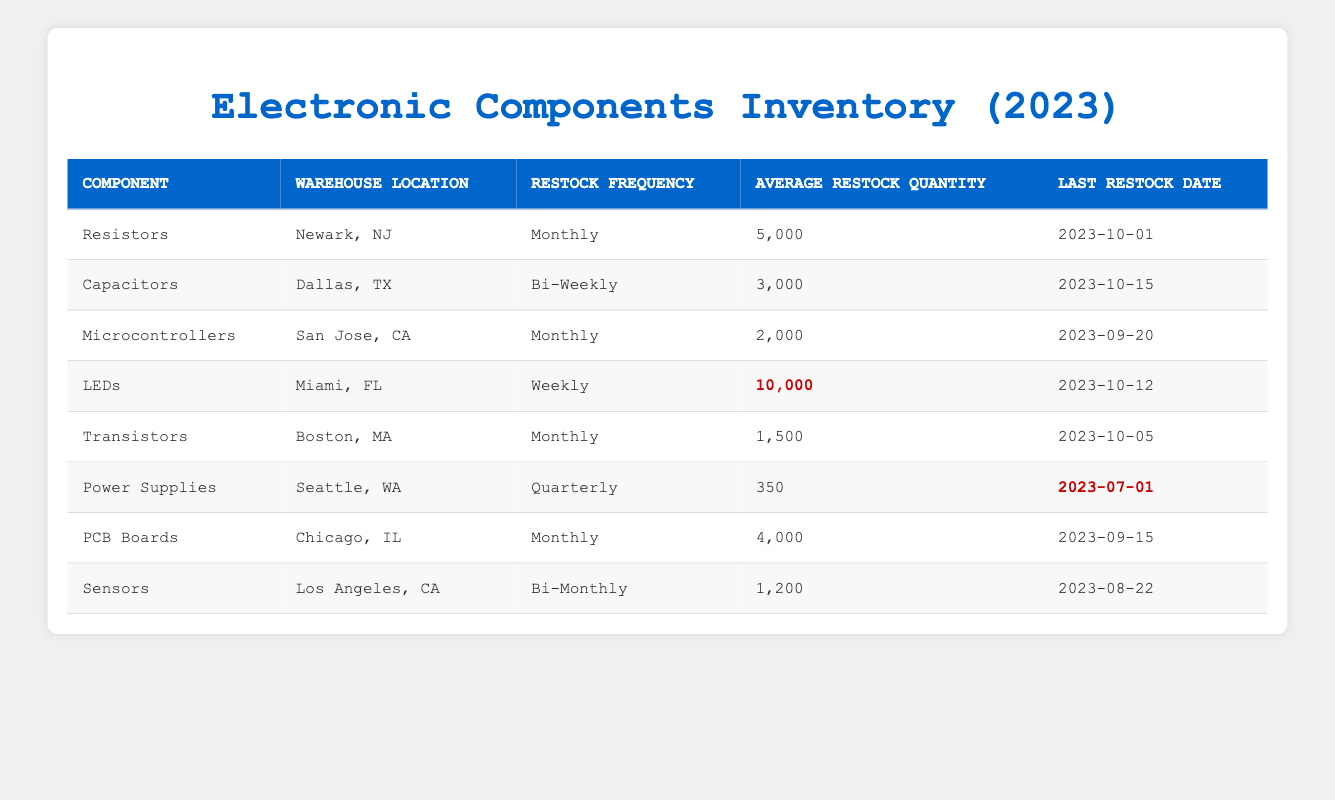What is the restock frequency of LEDs? The row for LEDs shows their Restock Frequency is Weekly.
Answer: Weekly How many components are restocked monthly? The table lists the components with restock frequency as Monthly: Resistors, Microcontrollers, Transistors, and PCB Boards. That totals to 4 components.
Answer: 4 Which component has the highest average restock quantity? By comparing the Average Restock Quantity, LEDs, with 10,000, is the highest value among the components listed.
Answer: 10,000 Is Power Supplies restocked more frequently than Sensors? Power Supplies have a Quarterly restock frequency while Sensors are Bi-Monthly. Quarterly means every three months, which is less frequent than Bi-Monthly (every two months). Therefore, the statement is false.
Answer: No What is the combined average restock quantity of the components that are restocked monthly? To find the combined average restock quantity of the monthly components: Resistors (5000) + Microcontrollers (2000) + Transistors (1500) + PCB Boards (4000) = 13,500. There are 4 components, so the average is 13,500/4 = 3,375.
Answer: 3,375 Which warehouse location has the last restock date among the components? Checking the Last Restock Date column, the latest date is for Capacitors at 2023-10-15.
Answer: Dallas, TX Are there any components with a restock frequency of Bi-Weekly? The table shows that Capacitors are listed with a Bi-Weekly restock frequency, meaning the answer is yes.
Answer: Yes Do all components with a monthly restock frequency have the same warehouse location? The monthly components are located in Newark, NJ (Resistors), San Jose, CA (Microcontrollers), Boston, MA (Transistors), and Chicago, IL (PCB Boards). Since they have different locations, the answer is no.
Answer: No What is the difference in average restock quantity between the LEDs and Power Supplies? The average restock quantity for LEDs is 10,000 and for Power Supplies is 350. The difference is 10,000 - 350 = 9,650.
Answer: 9,650 